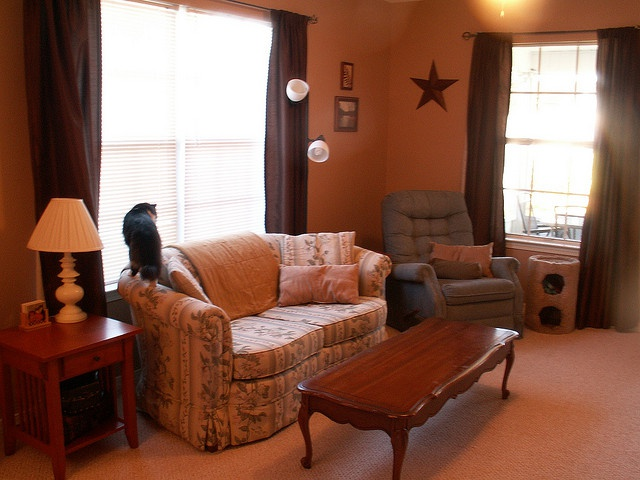Describe the objects in this image and their specific colors. I can see couch in maroon, brown, and lightpink tones, chair in maroon, black, and brown tones, couch in maroon, black, and brown tones, cat in maroon, black, gray, and white tones, and chair in maroon, white, darkgray, gray, and tan tones in this image. 